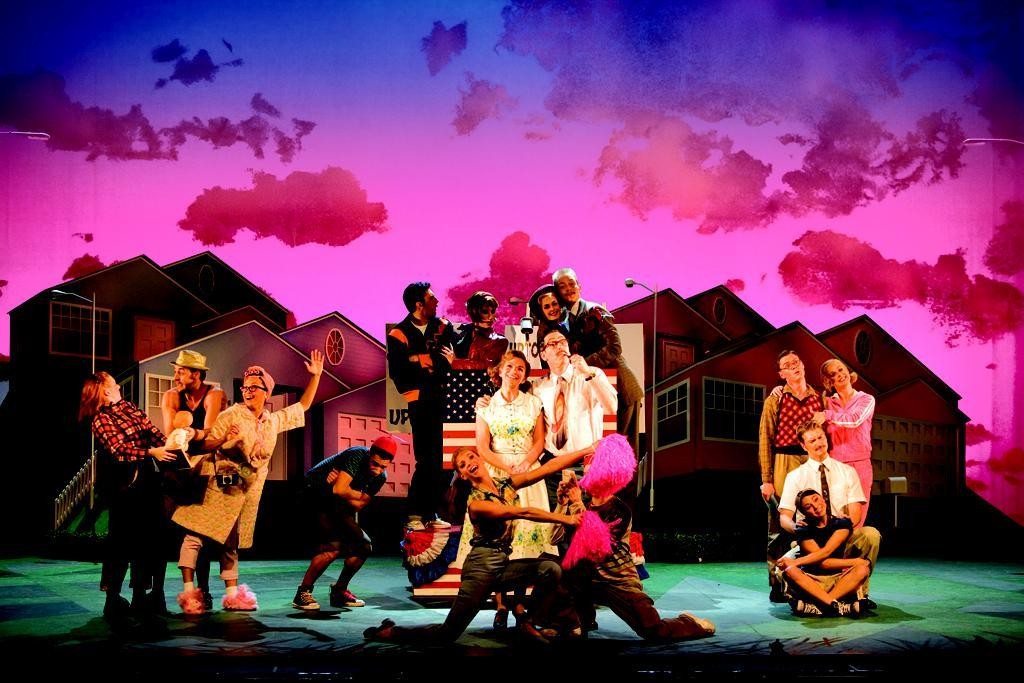How many people are in the image? There is a group of people in the image, but the exact number is not specified. What can be seen in the background of the image? There is a scenery in the background of the image. What color is the carpet in the image? The carpet in the image is green. What hobbies do the people in the image have? There is no information about the hobbies of the people in the image. Can you suggest a place where the people in the image might be going? There is no information about the destination or purpose of the people in the image, so it is not possible to suggest a place they might be going. 